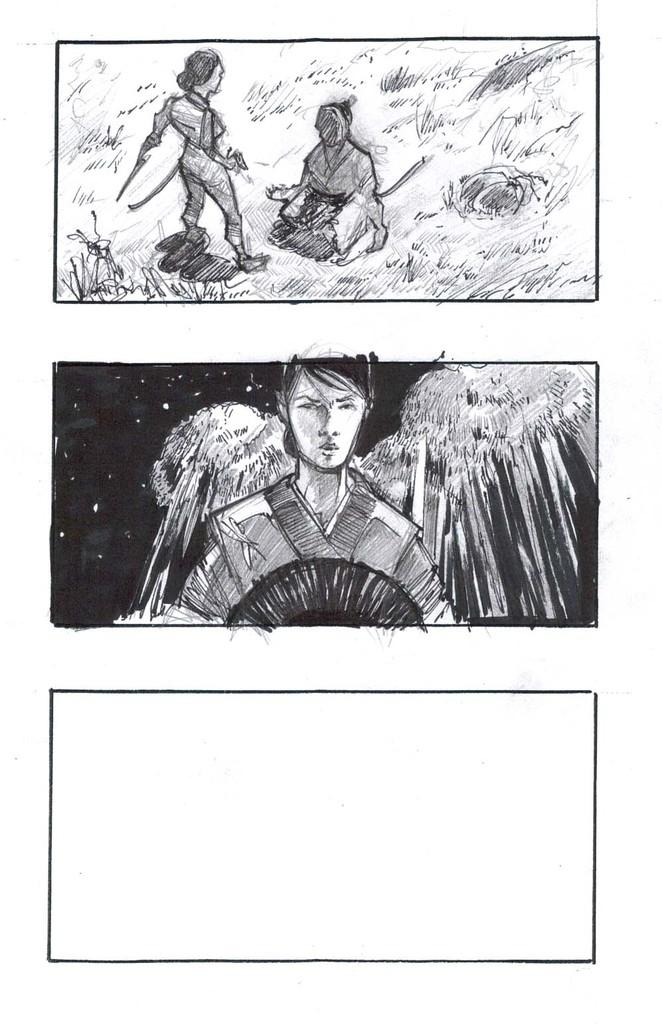What type of artwork is depicted in the image? The image appears to be a painting. How many persons are present in the painting? There are three persons in the painting. What type of terrain is visible in the painting? There is grass and stones in the painting. What else can be seen in the painting besides the persons and terrain? There are some objects in the painting. What is visible in the background of the painting? The sky is visible in the painting. Can you tell me where the kitty is sitting in the painting? There is no kitty present in the painting; it only features three persons, grass, stones, objects, and the sky. 